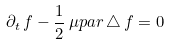Convert formula to latex. <formula><loc_0><loc_0><loc_500><loc_500>\partial _ { t } \, f - \frac { 1 } { 2 } \, \mu p a r \, \triangle \, f = 0</formula> 